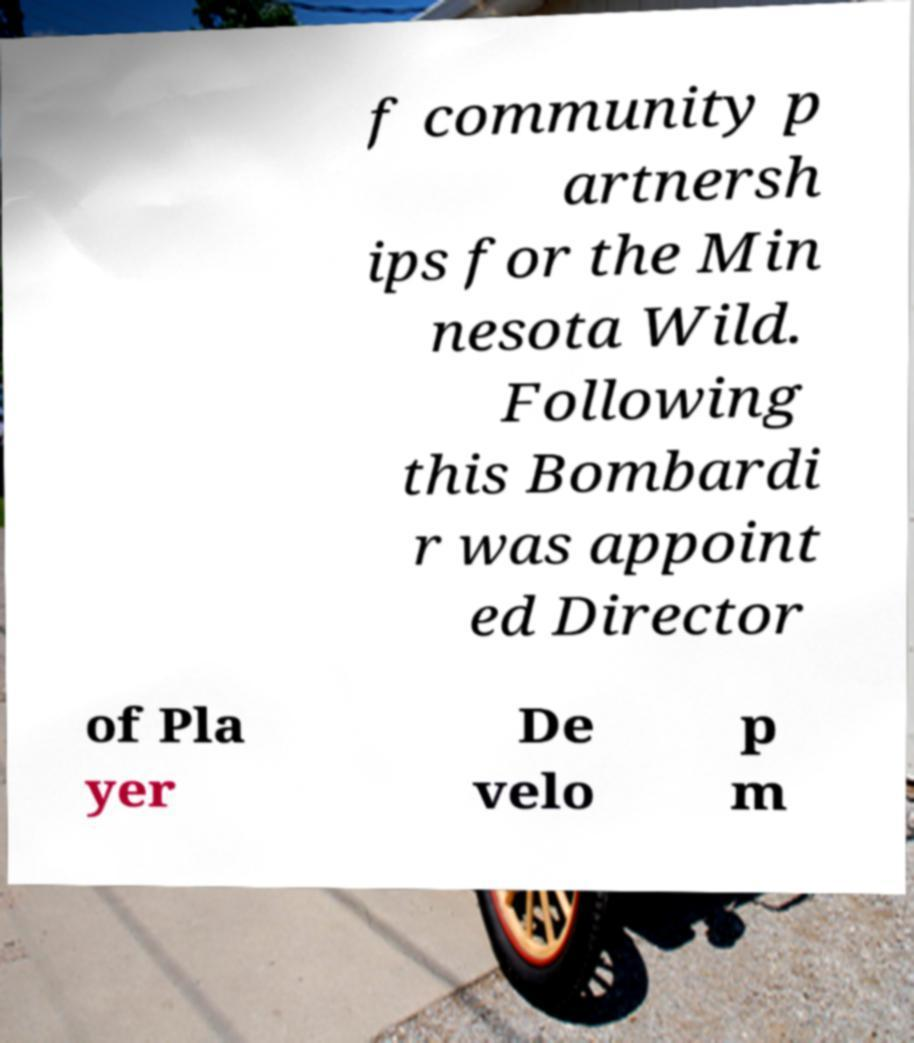I need the written content from this picture converted into text. Can you do that? f community p artnersh ips for the Min nesota Wild. Following this Bombardi r was appoint ed Director of Pla yer De velo p m 